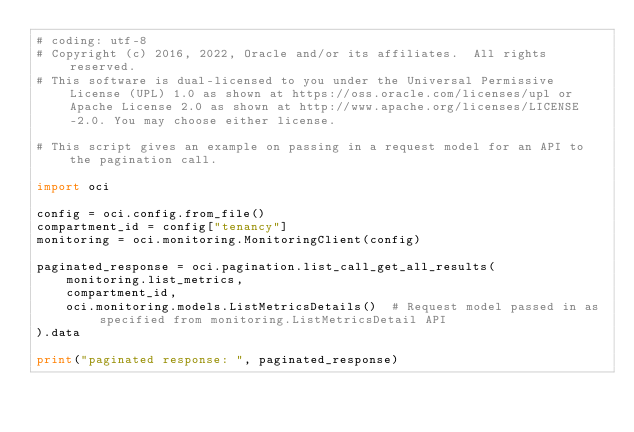Convert code to text. <code><loc_0><loc_0><loc_500><loc_500><_Python_># coding: utf-8
# Copyright (c) 2016, 2022, Oracle and/or its affiliates.  All rights reserved.
# This software is dual-licensed to you under the Universal Permissive License (UPL) 1.0 as shown at https://oss.oracle.com/licenses/upl or Apache License 2.0 as shown at http://www.apache.org/licenses/LICENSE-2.0. You may choose either license.

# This script gives an example on passing in a request model for an API to the pagination call.

import oci

config = oci.config.from_file()
compartment_id = config["tenancy"]
monitoring = oci.monitoring.MonitoringClient(config)

paginated_response = oci.pagination.list_call_get_all_results(
    monitoring.list_metrics,
    compartment_id,
    oci.monitoring.models.ListMetricsDetails()  # Request model passed in as specified from monitoring.ListMetricsDetail API
).data

print("paginated response: ", paginated_response)
</code> 